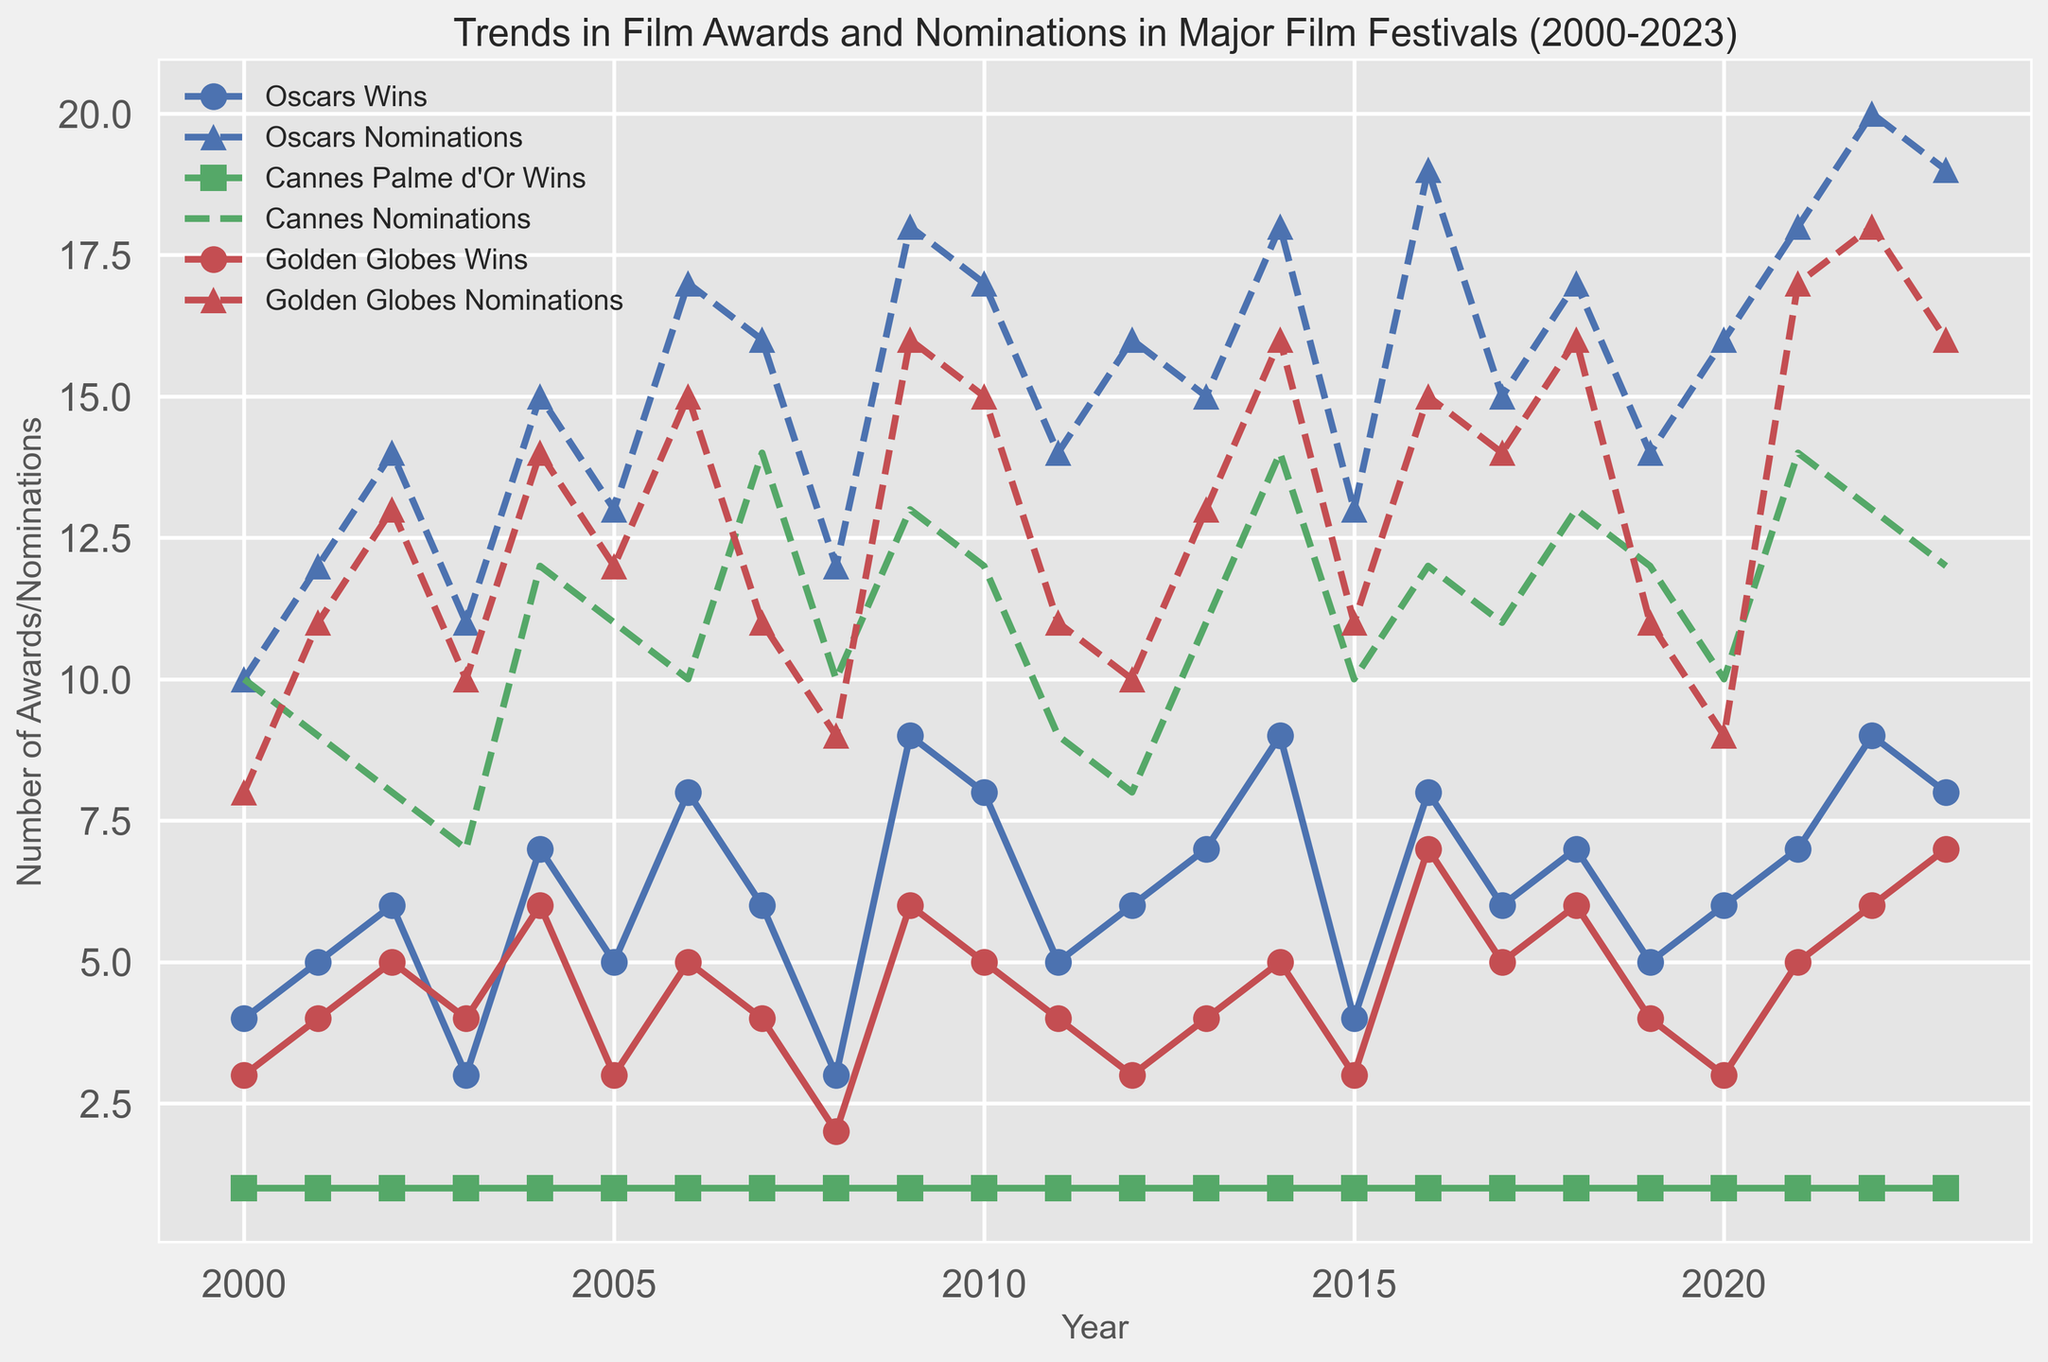Which festival had the highest number of wins in 2022? By looking at the lines with markers in the year 2022, we see the blue circles at 9 (Oscars Wins), green squares at 1 (Cannes Palme d'Or Wins), and red circles at 6 (Golden Globes Wins). So, Oscars had the highest number of wins.
Answer: Oscars Which festival showed the most significant increase in nominations from 2009 to 2010? Compare the slopes of the nomination lines between 2009 and 2010 for all festivals. The blue triangles (Oscars Nominations) go from 18 to 17 (change of -1), green crosses (Cannes Nominations) go from 13 to 12 (change of -1), and red triangles (Golden Globes Nominations) go from 16 to 15 (change of -1). Oscars showed a significant change of 1.
Answer: Oscars What is the difference in the number of Oscar wins between 2004 and 2011? Look at the blue circles for 2004 and 2011. The number of Oscars Wins in 2004 is 7, and in 2011 it is 5. The difference is 7 - 5 = 2.
Answer: 2 Which festival had consistent nominations of about 10 per year for Cannes Palme d'Or during the entire period? Observe the green cross line representing Cannes Nominations. It consistently hovers around 10 nominations each year.
Answer: Cannes In which year did the Golden Globes have their highest nominations? Follow the red triangle line (Golden Globes Nominations) and find the peak. The highest peak at 18 nominations occurs in 2022.
Answer: 2022 